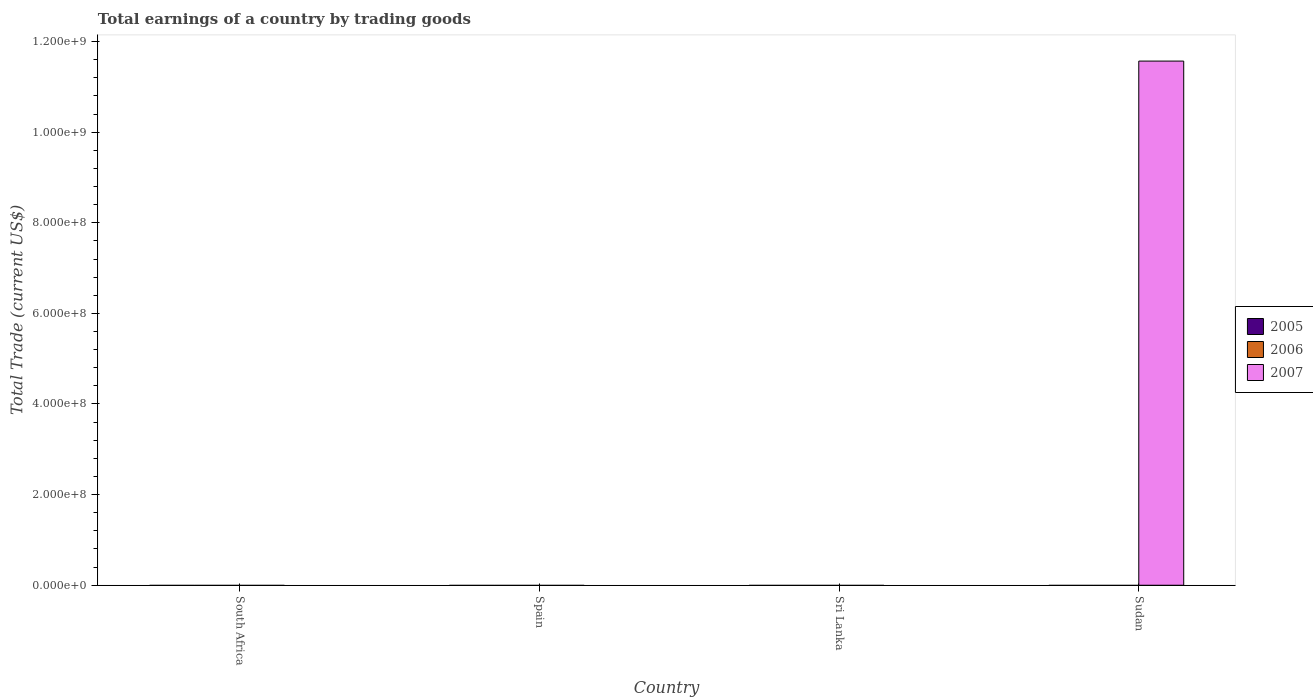Are the number of bars on each tick of the X-axis equal?
Ensure brevity in your answer.  No. How many bars are there on the 1st tick from the left?
Give a very brief answer. 0. How many bars are there on the 4th tick from the right?
Your answer should be very brief. 0. What is the label of the 4th group of bars from the left?
Ensure brevity in your answer.  Sudan. In how many cases, is the number of bars for a given country not equal to the number of legend labels?
Make the answer very short. 4. What is the total earnings in 2007 in Sudan?
Your answer should be compact. 1.16e+09. Across all countries, what is the maximum total earnings in 2007?
Offer a very short reply. 1.16e+09. Across all countries, what is the minimum total earnings in 2006?
Your answer should be very brief. 0. In which country was the total earnings in 2007 maximum?
Keep it short and to the point. Sudan. What is the difference between the total earnings in 2007 in Spain and the total earnings in 2006 in Sudan?
Ensure brevity in your answer.  0. What is the average total earnings in 2007 per country?
Make the answer very short. 2.89e+08. In how many countries, is the total earnings in 2005 greater than 960000000 US$?
Your answer should be compact. 0. What is the difference between the highest and the lowest total earnings in 2007?
Your answer should be compact. 1.16e+09. Is it the case that in every country, the sum of the total earnings in 2007 and total earnings in 2005 is greater than the total earnings in 2006?
Provide a short and direct response. No. Are all the bars in the graph horizontal?
Ensure brevity in your answer.  No. How many countries are there in the graph?
Keep it short and to the point. 4. Are the values on the major ticks of Y-axis written in scientific E-notation?
Offer a very short reply. Yes. Does the graph contain any zero values?
Offer a terse response. Yes. Where does the legend appear in the graph?
Offer a terse response. Center right. What is the title of the graph?
Offer a terse response. Total earnings of a country by trading goods. Does "1969" appear as one of the legend labels in the graph?
Provide a succinct answer. No. What is the label or title of the Y-axis?
Ensure brevity in your answer.  Total Trade (current US$). What is the Total Trade (current US$) of 2005 in Spain?
Offer a terse response. 0. What is the Total Trade (current US$) in 2007 in Spain?
Your answer should be compact. 0. What is the Total Trade (current US$) in 2005 in Sri Lanka?
Offer a very short reply. 0. What is the Total Trade (current US$) of 2006 in Sudan?
Give a very brief answer. 0. What is the Total Trade (current US$) of 2007 in Sudan?
Make the answer very short. 1.16e+09. Across all countries, what is the maximum Total Trade (current US$) of 2007?
Your answer should be very brief. 1.16e+09. What is the total Total Trade (current US$) in 2006 in the graph?
Offer a terse response. 0. What is the total Total Trade (current US$) of 2007 in the graph?
Your response must be concise. 1.16e+09. What is the average Total Trade (current US$) in 2007 per country?
Your answer should be very brief. 2.89e+08. What is the difference between the highest and the lowest Total Trade (current US$) in 2007?
Your response must be concise. 1.16e+09. 